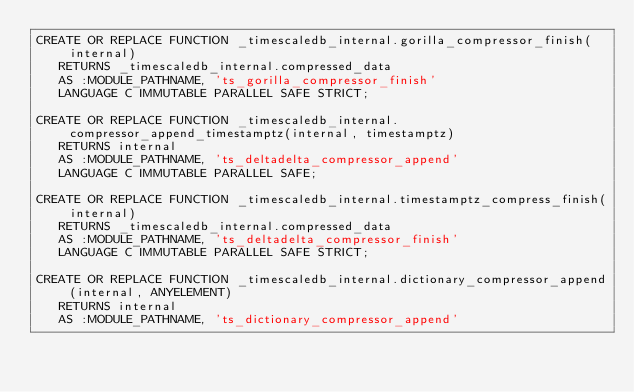<code> <loc_0><loc_0><loc_500><loc_500><_SQL_>CREATE OR REPLACE FUNCTION _timescaledb_internal.gorilla_compressor_finish(internal)
   RETURNS _timescaledb_internal.compressed_data
   AS :MODULE_PATHNAME, 'ts_gorilla_compressor_finish'
   LANGUAGE C IMMUTABLE PARALLEL SAFE STRICT;

CREATE OR REPLACE FUNCTION _timescaledb_internal.compressor_append_timestamptz(internal, timestamptz)
   RETURNS internal
   AS :MODULE_PATHNAME, 'ts_deltadelta_compressor_append'
   LANGUAGE C IMMUTABLE PARALLEL SAFE;

CREATE OR REPLACE FUNCTION _timescaledb_internal.timestamptz_compress_finish(internal)
   RETURNS _timescaledb_internal.compressed_data
   AS :MODULE_PATHNAME, 'ts_deltadelta_compressor_finish'
   LANGUAGE C IMMUTABLE PARALLEL SAFE STRICT;

CREATE OR REPLACE FUNCTION _timescaledb_internal.dictionary_compressor_append(internal, ANYELEMENT)
   RETURNS internal
   AS :MODULE_PATHNAME, 'ts_dictionary_compressor_append'</code> 